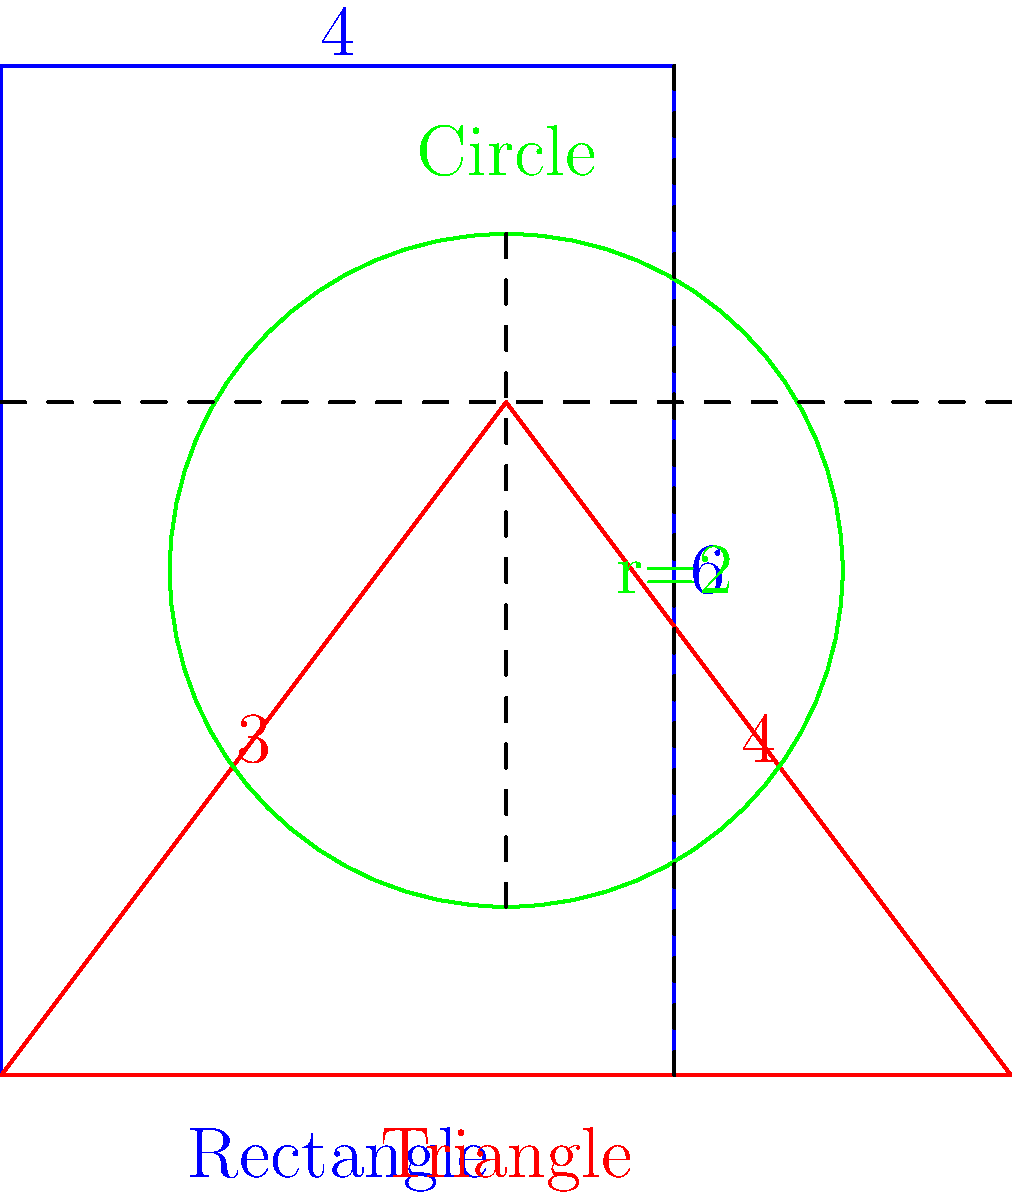As a fashion journalist familiar with Elsa Schiaparelli's innovative approach to fabric usage, estimate the minimum yardage of fabric needed to create a collection featuring a rectangular skirt, a triangular cape, and a circular hat. Assume the fabric is 45 inches wide and the shapes have the following dimensions: skirt (4x6 units), cape (6x4 units), and hat (diameter of 4 units). How many yards of fabric would be required, rounding up to the nearest quarter yard? Let's approach this step-by-step, channeling Schiaparelli's resourceful spirit:

1. Convert units to inches:
   Assume 1 unit = 10 inches
   Skirt: 40" x 60"
   Cape: 60" x 40"
   Hat: 40" diameter

2. Calculate area for each piece:
   Skirt (rectangle): $A = 40" \times 60" = 2400$ sq inches
   Cape (triangle): $A = \frac{1}{2} \times 60" \times 40" = 1200$ sq inches
   Hat (circle): $A = \pi r^2 = \pi \times 20^2 \approx 1257$ sq inches

3. Total area: $2400 + 1200 + 1257 = 4857$ sq inches

4. Fabric width is 45", so calculate length needed:
   $L = \frac{4857}{45} \approx 107.93$ inches

5. Convert to yards:
   $107.93 \div 36 \approx 3$ yards

6. Round up to the nearest quarter yard:
   3 yards → 3.25 yards

This approach ensures efficient use of fabric, much like Schiaparelli's innovative designs during fabric rationing in World War II.
Answer: 3.25 yards 